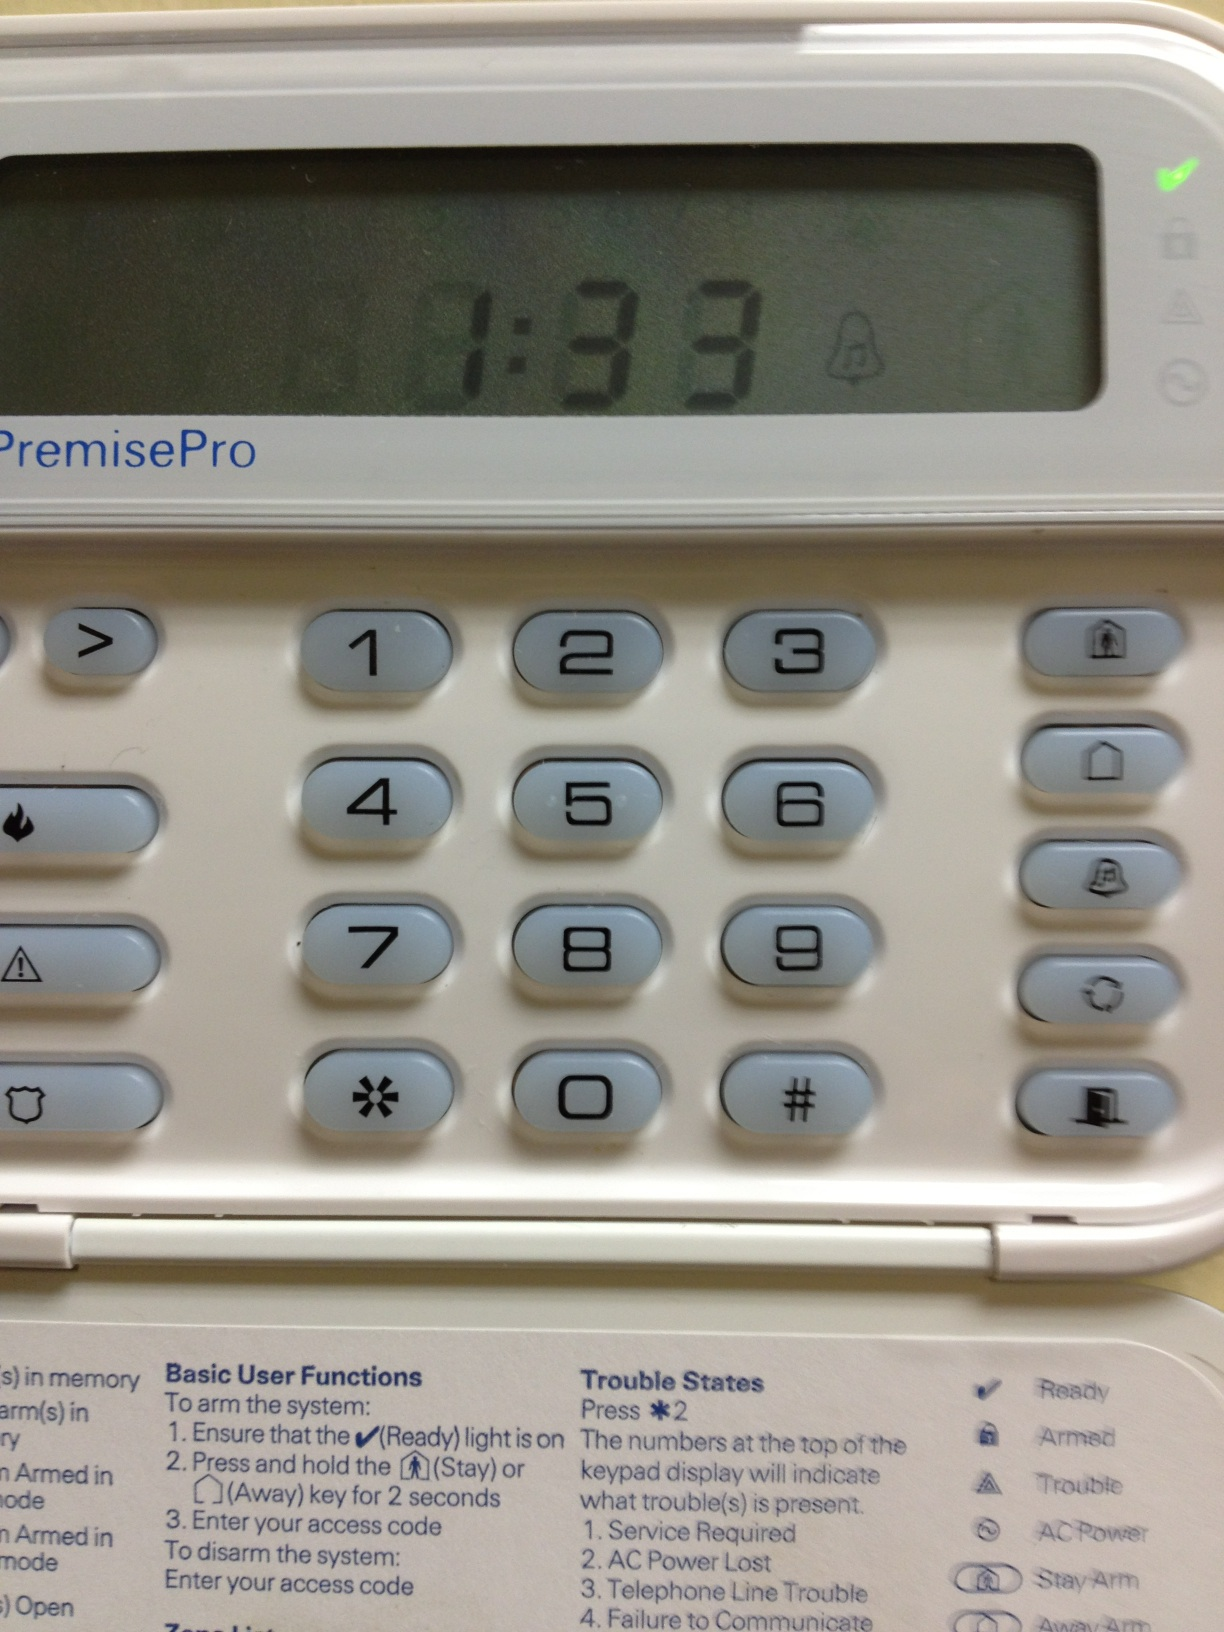How many numbers are on this item? On the security system keypad shown, there are 12 numbers visible, ranging from 0 to 9, including the '*' and '#' symbols, which are commonly used for additional functions. 